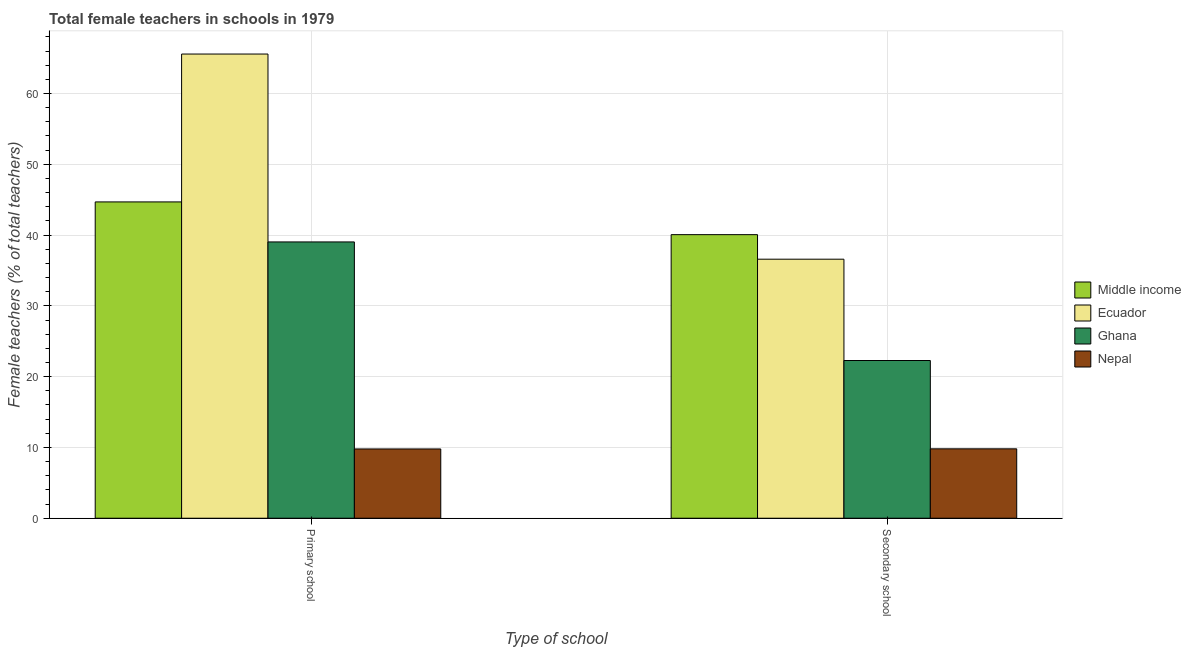How many groups of bars are there?
Your response must be concise. 2. Are the number of bars on each tick of the X-axis equal?
Make the answer very short. Yes. What is the label of the 1st group of bars from the left?
Offer a very short reply. Primary school. What is the percentage of female teachers in secondary schools in Ghana?
Your response must be concise. 22.28. Across all countries, what is the maximum percentage of female teachers in primary schools?
Your answer should be very brief. 65.58. Across all countries, what is the minimum percentage of female teachers in primary schools?
Keep it short and to the point. 9.79. In which country was the percentage of female teachers in secondary schools maximum?
Offer a terse response. Middle income. In which country was the percentage of female teachers in secondary schools minimum?
Offer a very short reply. Nepal. What is the total percentage of female teachers in primary schools in the graph?
Provide a short and direct response. 159.08. What is the difference between the percentage of female teachers in secondary schools in Ghana and that in Middle income?
Your response must be concise. -17.78. What is the difference between the percentage of female teachers in secondary schools in Nepal and the percentage of female teachers in primary schools in Ecuador?
Make the answer very short. -55.77. What is the average percentage of female teachers in secondary schools per country?
Make the answer very short. 27.18. What is the difference between the percentage of female teachers in primary schools and percentage of female teachers in secondary schools in Ghana?
Ensure brevity in your answer.  16.75. In how many countries, is the percentage of female teachers in secondary schools greater than 36 %?
Provide a succinct answer. 2. What is the ratio of the percentage of female teachers in primary schools in Middle income to that in Nepal?
Your answer should be very brief. 4.57. In how many countries, is the percentage of female teachers in primary schools greater than the average percentage of female teachers in primary schools taken over all countries?
Offer a very short reply. 2. What does the 4th bar from the left in Primary school represents?
Provide a short and direct response. Nepal. What does the 2nd bar from the right in Secondary school represents?
Ensure brevity in your answer.  Ghana. How many countries are there in the graph?
Provide a succinct answer. 4. What is the difference between two consecutive major ticks on the Y-axis?
Make the answer very short. 10. Where does the legend appear in the graph?
Your answer should be very brief. Center right. How many legend labels are there?
Make the answer very short. 4. What is the title of the graph?
Offer a very short reply. Total female teachers in schools in 1979. What is the label or title of the X-axis?
Give a very brief answer. Type of school. What is the label or title of the Y-axis?
Give a very brief answer. Female teachers (% of total teachers). What is the Female teachers (% of total teachers) in Middle income in Primary school?
Your answer should be very brief. 44.68. What is the Female teachers (% of total teachers) in Ecuador in Primary school?
Your answer should be very brief. 65.58. What is the Female teachers (% of total teachers) in Ghana in Primary school?
Provide a succinct answer. 39.03. What is the Female teachers (% of total teachers) in Nepal in Primary school?
Make the answer very short. 9.79. What is the Female teachers (% of total teachers) in Middle income in Secondary school?
Keep it short and to the point. 40.06. What is the Female teachers (% of total teachers) in Ecuador in Secondary school?
Give a very brief answer. 36.59. What is the Female teachers (% of total teachers) of Ghana in Secondary school?
Your response must be concise. 22.28. What is the Female teachers (% of total teachers) in Nepal in Secondary school?
Provide a short and direct response. 9.8. Across all Type of school, what is the maximum Female teachers (% of total teachers) of Middle income?
Your response must be concise. 44.68. Across all Type of school, what is the maximum Female teachers (% of total teachers) in Ecuador?
Make the answer very short. 65.58. Across all Type of school, what is the maximum Female teachers (% of total teachers) in Ghana?
Keep it short and to the point. 39.03. Across all Type of school, what is the maximum Female teachers (% of total teachers) in Nepal?
Keep it short and to the point. 9.8. Across all Type of school, what is the minimum Female teachers (% of total teachers) in Middle income?
Your answer should be very brief. 40.06. Across all Type of school, what is the minimum Female teachers (% of total teachers) in Ecuador?
Your answer should be compact. 36.59. Across all Type of school, what is the minimum Female teachers (% of total teachers) in Ghana?
Offer a very short reply. 22.28. Across all Type of school, what is the minimum Female teachers (% of total teachers) of Nepal?
Make the answer very short. 9.79. What is the total Female teachers (% of total teachers) of Middle income in the graph?
Your answer should be compact. 84.75. What is the total Female teachers (% of total teachers) in Ecuador in the graph?
Provide a succinct answer. 102.17. What is the total Female teachers (% of total teachers) of Ghana in the graph?
Offer a very short reply. 61.31. What is the total Female teachers (% of total teachers) in Nepal in the graph?
Offer a very short reply. 19.59. What is the difference between the Female teachers (% of total teachers) in Middle income in Primary school and that in Secondary school?
Provide a succinct answer. 4.62. What is the difference between the Female teachers (% of total teachers) of Ecuador in Primary school and that in Secondary school?
Give a very brief answer. 28.98. What is the difference between the Female teachers (% of total teachers) in Ghana in Primary school and that in Secondary school?
Your response must be concise. 16.75. What is the difference between the Female teachers (% of total teachers) of Nepal in Primary school and that in Secondary school?
Make the answer very short. -0.02. What is the difference between the Female teachers (% of total teachers) of Middle income in Primary school and the Female teachers (% of total teachers) of Ecuador in Secondary school?
Give a very brief answer. 8.09. What is the difference between the Female teachers (% of total teachers) in Middle income in Primary school and the Female teachers (% of total teachers) in Ghana in Secondary school?
Keep it short and to the point. 22.4. What is the difference between the Female teachers (% of total teachers) of Middle income in Primary school and the Female teachers (% of total teachers) of Nepal in Secondary school?
Offer a terse response. 34.88. What is the difference between the Female teachers (% of total teachers) of Ecuador in Primary school and the Female teachers (% of total teachers) of Ghana in Secondary school?
Make the answer very short. 43.29. What is the difference between the Female teachers (% of total teachers) in Ecuador in Primary school and the Female teachers (% of total teachers) in Nepal in Secondary school?
Make the answer very short. 55.77. What is the difference between the Female teachers (% of total teachers) in Ghana in Primary school and the Female teachers (% of total teachers) in Nepal in Secondary school?
Make the answer very short. 29.23. What is the average Female teachers (% of total teachers) in Middle income per Type of school?
Provide a succinct answer. 42.37. What is the average Female teachers (% of total teachers) in Ecuador per Type of school?
Keep it short and to the point. 51.08. What is the average Female teachers (% of total teachers) in Ghana per Type of school?
Your response must be concise. 30.66. What is the average Female teachers (% of total teachers) in Nepal per Type of school?
Keep it short and to the point. 9.79. What is the difference between the Female teachers (% of total teachers) in Middle income and Female teachers (% of total teachers) in Ecuador in Primary school?
Give a very brief answer. -20.89. What is the difference between the Female teachers (% of total teachers) of Middle income and Female teachers (% of total teachers) of Ghana in Primary school?
Your answer should be very brief. 5.65. What is the difference between the Female teachers (% of total teachers) in Middle income and Female teachers (% of total teachers) in Nepal in Primary school?
Your response must be concise. 34.9. What is the difference between the Female teachers (% of total teachers) in Ecuador and Female teachers (% of total teachers) in Ghana in Primary school?
Offer a terse response. 26.54. What is the difference between the Female teachers (% of total teachers) of Ecuador and Female teachers (% of total teachers) of Nepal in Primary school?
Your response must be concise. 55.79. What is the difference between the Female teachers (% of total teachers) of Ghana and Female teachers (% of total teachers) of Nepal in Primary school?
Your response must be concise. 29.25. What is the difference between the Female teachers (% of total teachers) of Middle income and Female teachers (% of total teachers) of Ecuador in Secondary school?
Your answer should be very brief. 3.47. What is the difference between the Female teachers (% of total teachers) of Middle income and Female teachers (% of total teachers) of Ghana in Secondary school?
Give a very brief answer. 17.78. What is the difference between the Female teachers (% of total teachers) of Middle income and Female teachers (% of total teachers) of Nepal in Secondary school?
Offer a terse response. 30.26. What is the difference between the Female teachers (% of total teachers) in Ecuador and Female teachers (% of total teachers) in Ghana in Secondary school?
Offer a very short reply. 14.31. What is the difference between the Female teachers (% of total teachers) in Ecuador and Female teachers (% of total teachers) in Nepal in Secondary school?
Provide a short and direct response. 26.79. What is the difference between the Female teachers (% of total teachers) in Ghana and Female teachers (% of total teachers) in Nepal in Secondary school?
Give a very brief answer. 12.48. What is the ratio of the Female teachers (% of total teachers) in Middle income in Primary school to that in Secondary school?
Offer a terse response. 1.12. What is the ratio of the Female teachers (% of total teachers) of Ecuador in Primary school to that in Secondary school?
Your answer should be very brief. 1.79. What is the ratio of the Female teachers (% of total teachers) in Ghana in Primary school to that in Secondary school?
Ensure brevity in your answer.  1.75. What is the ratio of the Female teachers (% of total teachers) of Nepal in Primary school to that in Secondary school?
Offer a very short reply. 1. What is the difference between the highest and the second highest Female teachers (% of total teachers) in Middle income?
Offer a very short reply. 4.62. What is the difference between the highest and the second highest Female teachers (% of total teachers) in Ecuador?
Provide a short and direct response. 28.98. What is the difference between the highest and the second highest Female teachers (% of total teachers) of Ghana?
Ensure brevity in your answer.  16.75. What is the difference between the highest and the second highest Female teachers (% of total teachers) in Nepal?
Your response must be concise. 0.02. What is the difference between the highest and the lowest Female teachers (% of total teachers) in Middle income?
Make the answer very short. 4.62. What is the difference between the highest and the lowest Female teachers (% of total teachers) in Ecuador?
Ensure brevity in your answer.  28.98. What is the difference between the highest and the lowest Female teachers (% of total teachers) in Ghana?
Your answer should be very brief. 16.75. What is the difference between the highest and the lowest Female teachers (% of total teachers) in Nepal?
Your answer should be very brief. 0.02. 